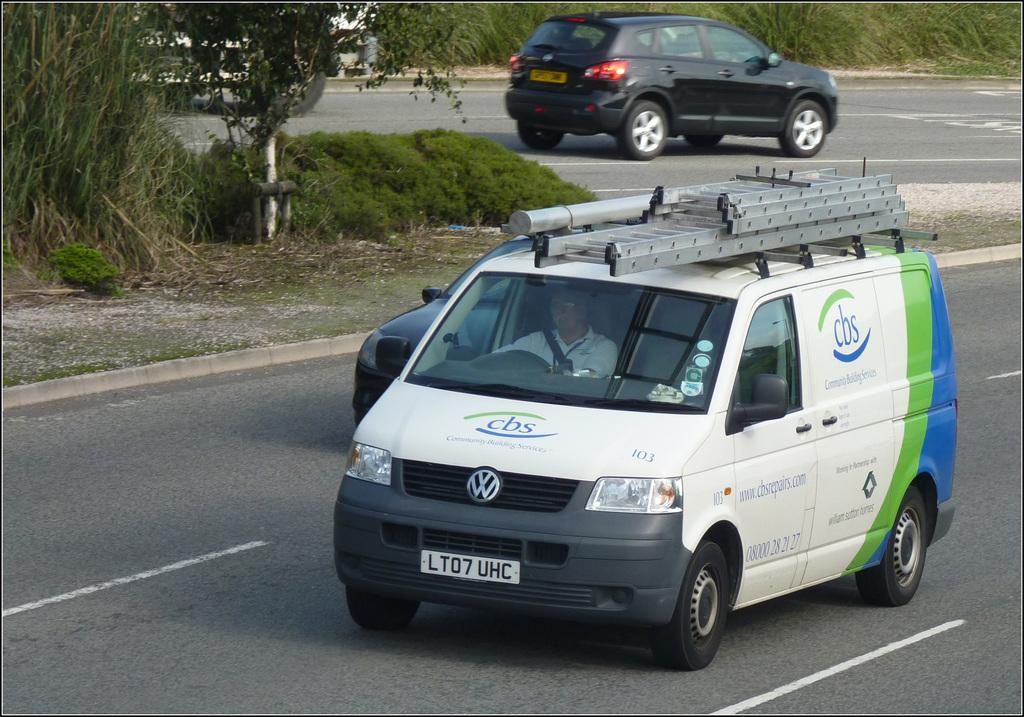What type of vehicle is in the image? There is a van in the image. How many other vehicles are in the image? There are two cars in the image. Where are the vehicles located? The vehicles are traveling on a road. Can you describe the presence of a person in the image? There is a person inside the van. What type of vegetation can be seen in the image? There is a tree on the left side of the image, and grass is visible. What type of zinc can be seen in the image? There is no zinc present in the image. Is there a stream visible in the image? No, there is no stream visible in the image. 